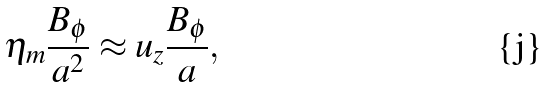Convert formula to latex. <formula><loc_0><loc_0><loc_500><loc_500>\eta _ { m } \frac { B _ { \phi } } { a ^ { 2 } } \approx u _ { z } \frac { B _ { \phi } } { a } ,</formula> 